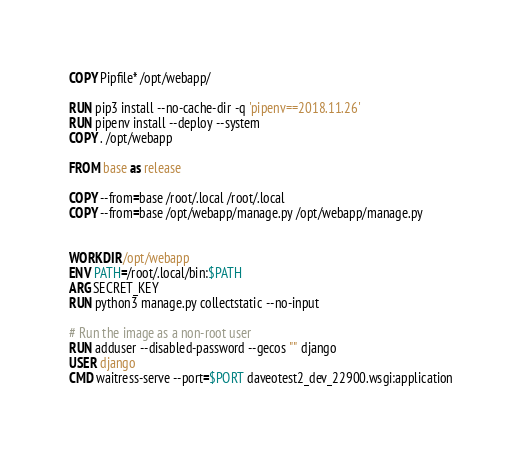<code> <loc_0><loc_0><loc_500><loc_500><_Dockerfile_>COPY Pipfile* /opt/webapp/

RUN pip3 install --no-cache-dir -q 'pipenv==2018.11.26' 
RUN pipenv install --deploy --system
COPY . /opt/webapp

FROM base as release

COPY --from=base /root/.local /root/.local
COPY --from=base /opt/webapp/manage.py /opt/webapp/manage.py


WORKDIR /opt/webapp
ENV PATH=/root/.local/bin:$PATH
ARG SECRET_KEY 
RUN python3 manage.py collectstatic --no-input

# Run the image as a non-root user
RUN adduser --disabled-password --gecos "" django
USER django
CMD waitress-serve --port=$PORT daveotest2_dev_22900.wsgi:application
</code> 